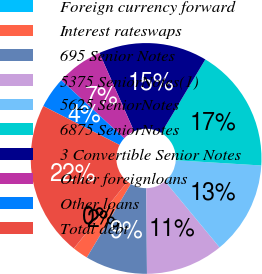Convert chart to OTSL. <chart><loc_0><loc_0><loc_500><loc_500><pie_chart><fcel>Foreign currency forward<fcel>Interest rateswaps<fcel>695 Senior Notes<fcel>5375 SeniorNotes(1)<fcel>5625 SeniorNotes<fcel>6875 SeniorNotes<fcel>3 Convertible Senior Notes<fcel>Other foreignloans<fcel>Other loans<fcel>Total debt<nl><fcel>0.01%<fcel>2.18%<fcel>8.7%<fcel>10.87%<fcel>13.04%<fcel>17.39%<fcel>15.21%<fcel>6.52%<fcel>4.35%<fcel>21.73%<nl></chart> 